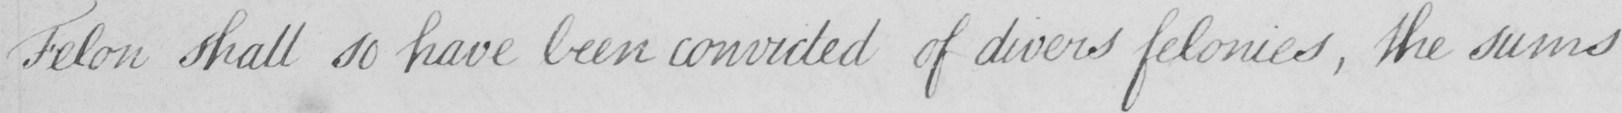Please provide the text content of this handwritten line. Felon shall so have been convicted of divers felonies , the sums 